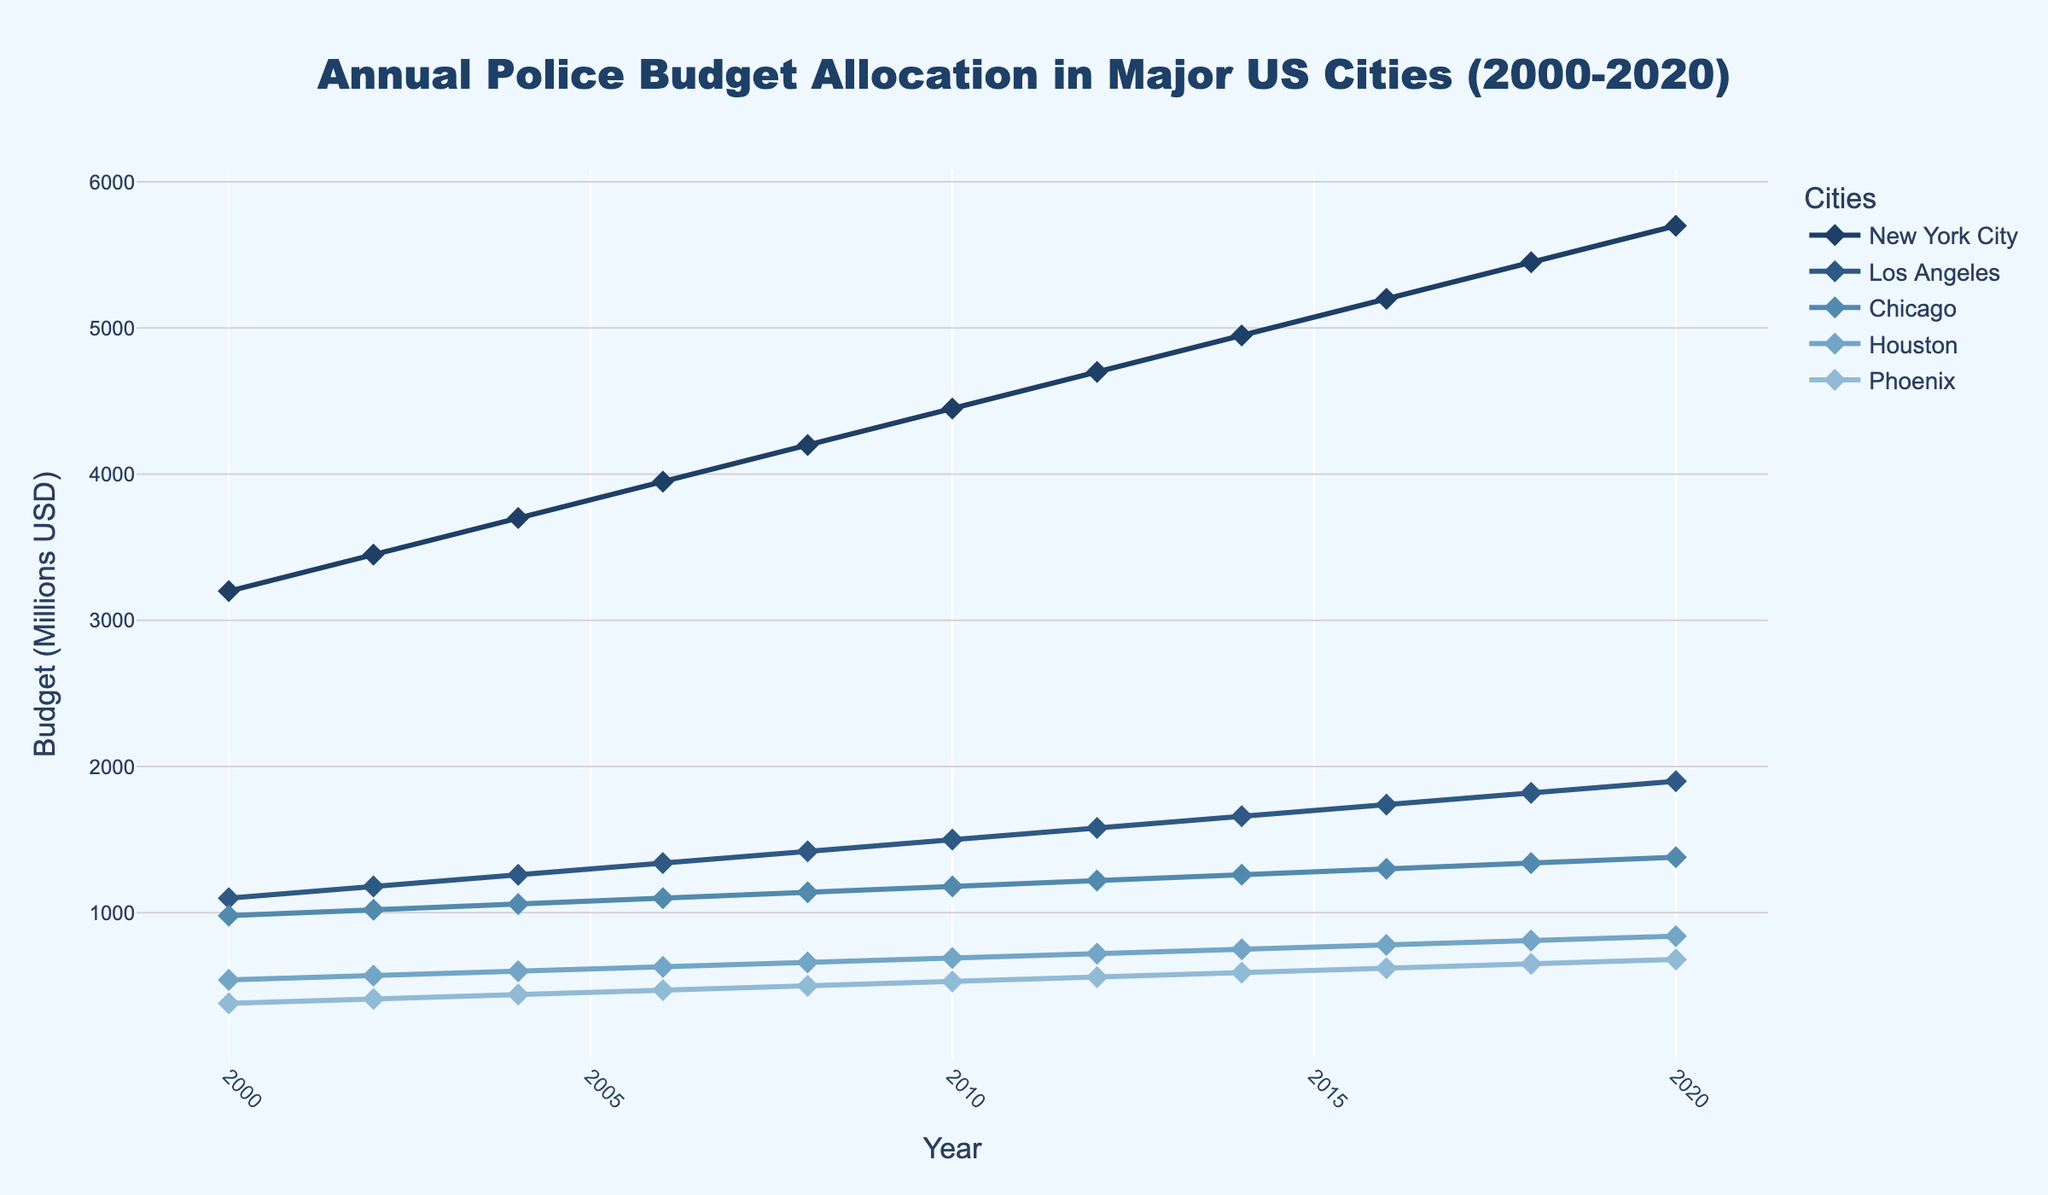What's the average annual budget for New York City from 2000 to 2020? To find the average, sum the budgets for New York City from 2000 to 2020 and then divide by the number of years. (3200 + 3450 + 3700 + 3950 + 4200 + 4450 + 4700 + 4950 + 5200 + 5450 + 5700) / 11 = 4290.91
Answer: 4290.91 How has the budget for Chicago changed from 2000 to 2020? Subtract the budget of 2000 from the budget of 2020 for Chicago. 1380 - 980 = 400
Answer: 400 Which city saw the largest increase in budget allocation from 2000 to 2020? Compare the changes in budgets for all cities by subtracting their budgets in 2000 from those in 2020: NYC (5700 - 3200 = 2500), LA (1900 - 1100 = 800), Chicago (1380 - 980 = 400), Houston (840 - 540 = 300), Phoenix (680 - 380 = 300). New York City has the largest increase.
Answer: New York City What was the total budget allocation for all five cities combined in 2010? Add the budgets for all five cities in 2010. 4450 + 1500 + 1180 + 690 + 530 = 10350
Answer: 10350 In which year did Los Angeles surpass a budget of 1500 million USD? Look at the budget trend for Los Angeles and identify the first year it is greater than 1500 million: 1580 in 2012.
Answer: 2012 Which city had the lowest budget in 2020? Compare the budget allocations for all cities in 2020: NYC (5700), LA (1900), Chicago (1380), Houston (840), Phoenix (680). Phoenix has the lowest budget.
Answer: Phoenix By how much did Houston's budget increase between 2006 and 2016? Subtract Houston's budget in 2006 from that in 2016. 780 - 630 = 150
Answer: 150 What's the sum of Phoenix's budgets from 2000 to 2020? Add Phoenix's budgets for all years. 380 + 410 + 440 + 470 + 500 + 530 + 560 + 590 + 620 + 650 + 680 = 5830
Answer: 5830 Which city had the most stable budget growth over the period 2000-2020? Analyze the budget trends to determine which city had the most consistent increase: based on the given data, Los Angeles shows a steady linear increase every two years.
Answer: Los Angeles What was the cumulative increase in budget for all cities from 2000 to 2020? Calculate the difference in budget for each city from 2000 to 2020 and then sum these differences: (2500 for NYC) + (800 for LA) + (400 for Chicago) + (300 for Houston) + (300 for Phoenix) = 4300
Answer: 4300 